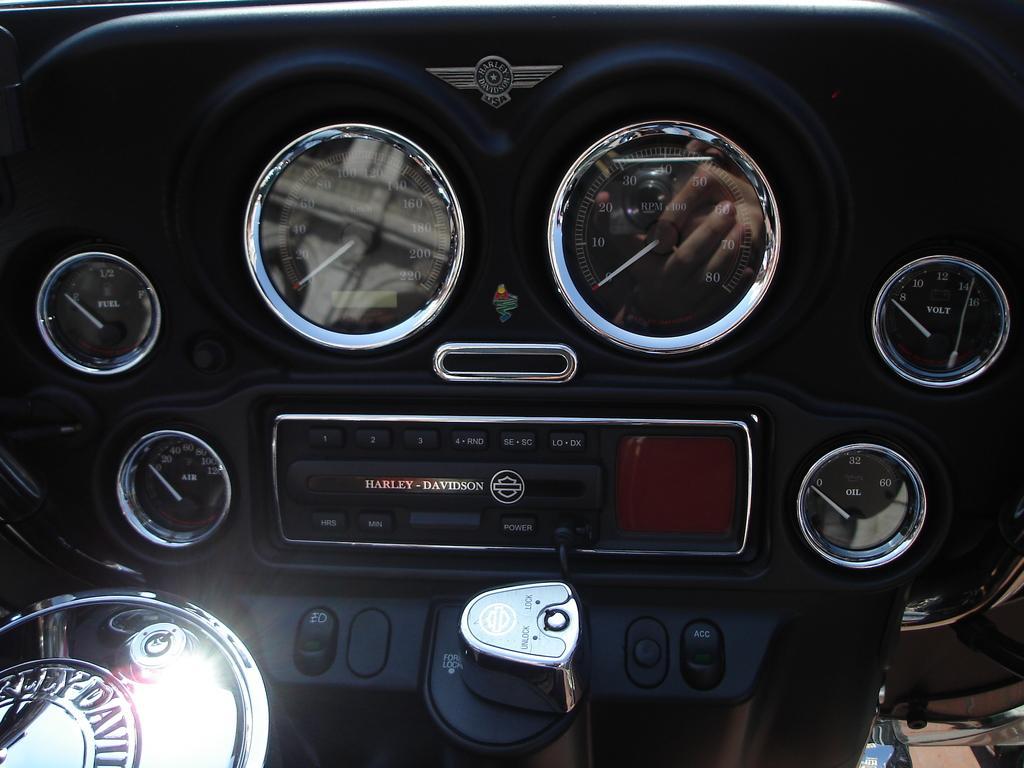Please provide a concise description of this image. In this image we can see a bike front part, there is a speedometer, fuel meter, air, and oil meters, also we can see some buttons. 